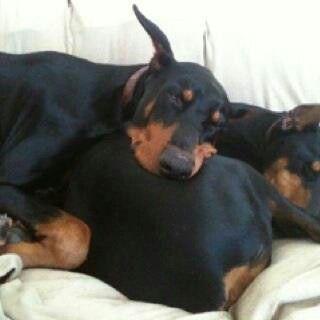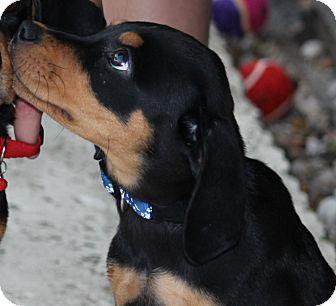The first image is the image on the left, the second image is the image on the right. For the images shown, is this caption "Each image shows one forward-facing adult doberman with pointy erect ears." true? Answer yes or no. No. 